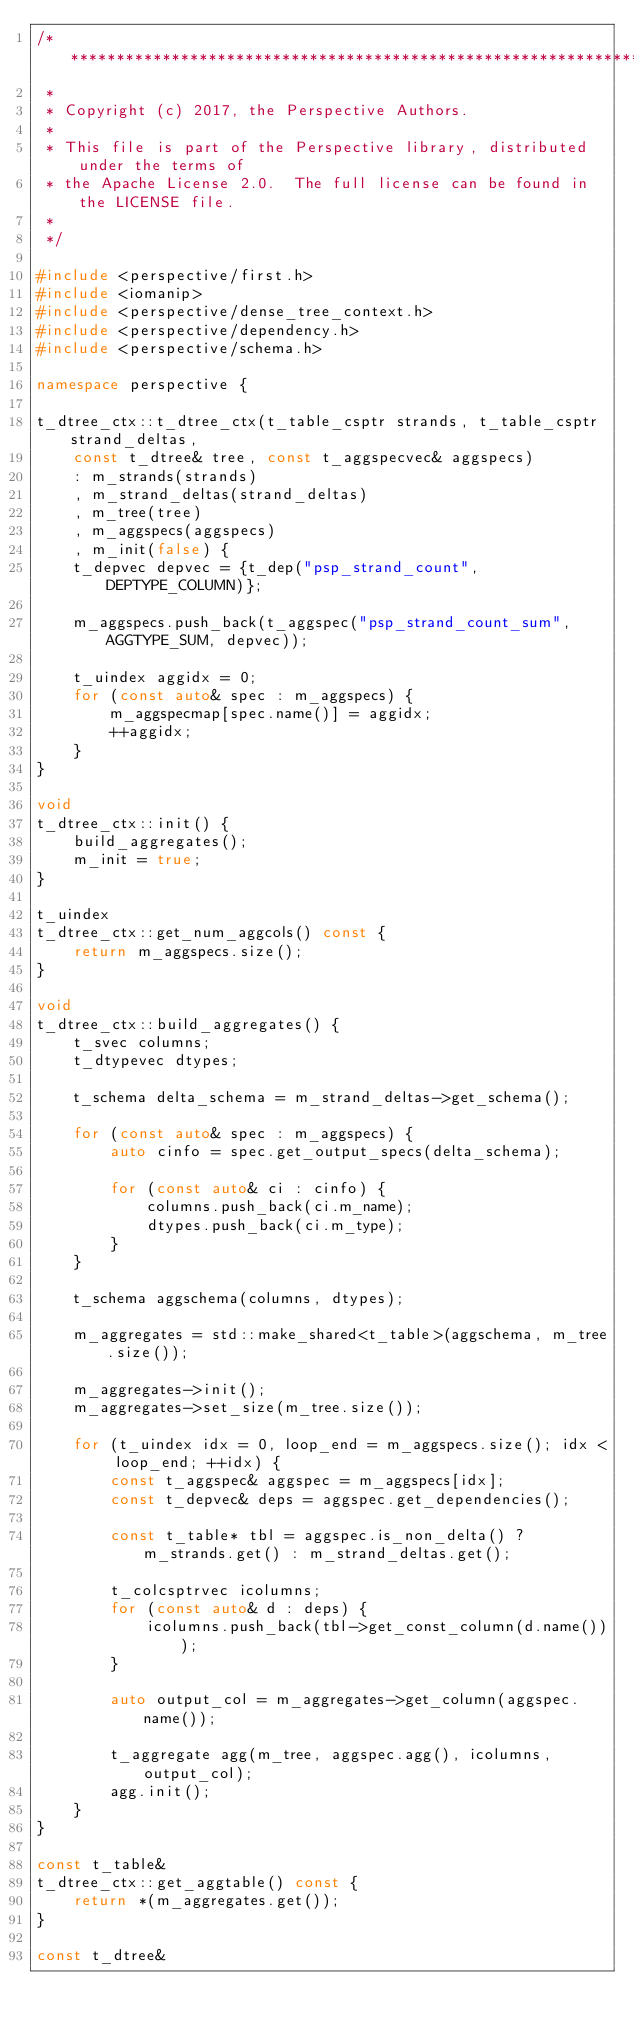<code> <loc_0><loc_0><loc_500><loc_500><_C++_>/******************************************************************************
 *
 * Copyright (c) 2017, the Perspective Authors.
 *
 * This file is part of the Perspective library, distributed under the terms of
 * the Apache License 2.0.  The full license can be found in the LICENSE file.
 *
 */

#include <perspective/first.h>
#include <iomanip>
#include <perspective/dense_tree_context.h>
#include <perspective/dependency.h>
#include <perspective/schema.h>

namespace perspective {

t_dtree_ctx::t_dtree_ctx(t_table_csptr strands, t_table_csptr strand_deltas,
    const t_dtree& tree, const t_aggspecvec& aggspecs)
    : m_strands(strands)
    , m_strand_deltas(strand_deltas)
    , m_tree(tree)
    , m_aggspecs(aggspecs)
    , m_init(false) {
    t_depvec depvec = {t_dep("psp_strand_count", DEPTYPE_COLUMN)};

    m_aggspecs.push_back(t_aggspec("psp_strand_count_sum", AGGTYPE_SUM, depvec));

    t_uindex aggidx = 0;
    for (const auto& spec : m_aggspecs) {
        m_aggspecmap[spec.name()] = aggidx;
        ++aggidx;
    }
}

void
t_dtree_ctx::init() {
    build_aggregates();
    m_init = true;
}

t_uindex
t_dtree_ctx::get_num_aggcols() const {
    return m_aggspecs.size();
}

void
t_dtree_ctx::build_aggregates() {
    t_svec columns;
    t_dtypevec dtypes;

    t_schema delta_schema = m_strand_deltas->get_schema();

    for (const auto& spec : m_aggspecs) {
        auto cinfo = spec.get_output_specs(delta_schema);

        for (const auto& ci : cinfo) {
            columns.push_back(ci.m_name);
            dtypes.push_back(ci.m_type);
        }
    }

    t_schema aggschema(columns, dtypes);

    m_aggregates = std::make_shared<t_table>(aggschema, m_tree.size());

    m_aggregates->init();
    m_aggregates->set_size(m_tree.size());

    for (t_uindex idx = 0, loop_end = m_aggspecs.size(); idx < loop_end; ++idx) {
        const t_aggspec& aggspec = m_aggspecs[idx];
        const t_depvec& deps = aggspec.get_dependencies();

        const t_table* tbl = aggspec.is_non_delta() ? m_strands.get() : m_strand_deltas.get();

        t_colcsptrvec icolumns;
        for (const auto& d : deps) {
            icolumns.push_back(tbl->get_const_column(d.name()));
        }

        auto output_col = m_aggregates->get_column(aggspec.name());

        t_aggregate agg(m_tree, aggspec.agg(), icolumns, output_col);
        agg.init();
    }
}

const t_table&
t_dtree_ctx::get_aggtable() const {
    return *(m_aggregates.get());
}

const t_dtree&</code> 